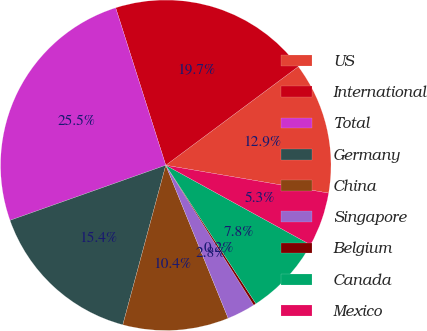<chart> <loc_0><loc_0><loc_500><loc_500><pie_chart><fcel>US<fcel>International<fcel>Total<fcel>Germany<fcel>China<fcel>Singapore<fcel>Belgium<fcel>Canada<fcel>Mexico<nl><fcel>12.88%<fcel>19.72%<fcel>25.51%<fcel>15.4%<fcel>10.35%<fcel>2.77%<fcel>0.25%<fcel>7.82%<fcel>5.3%<nl></chart> 